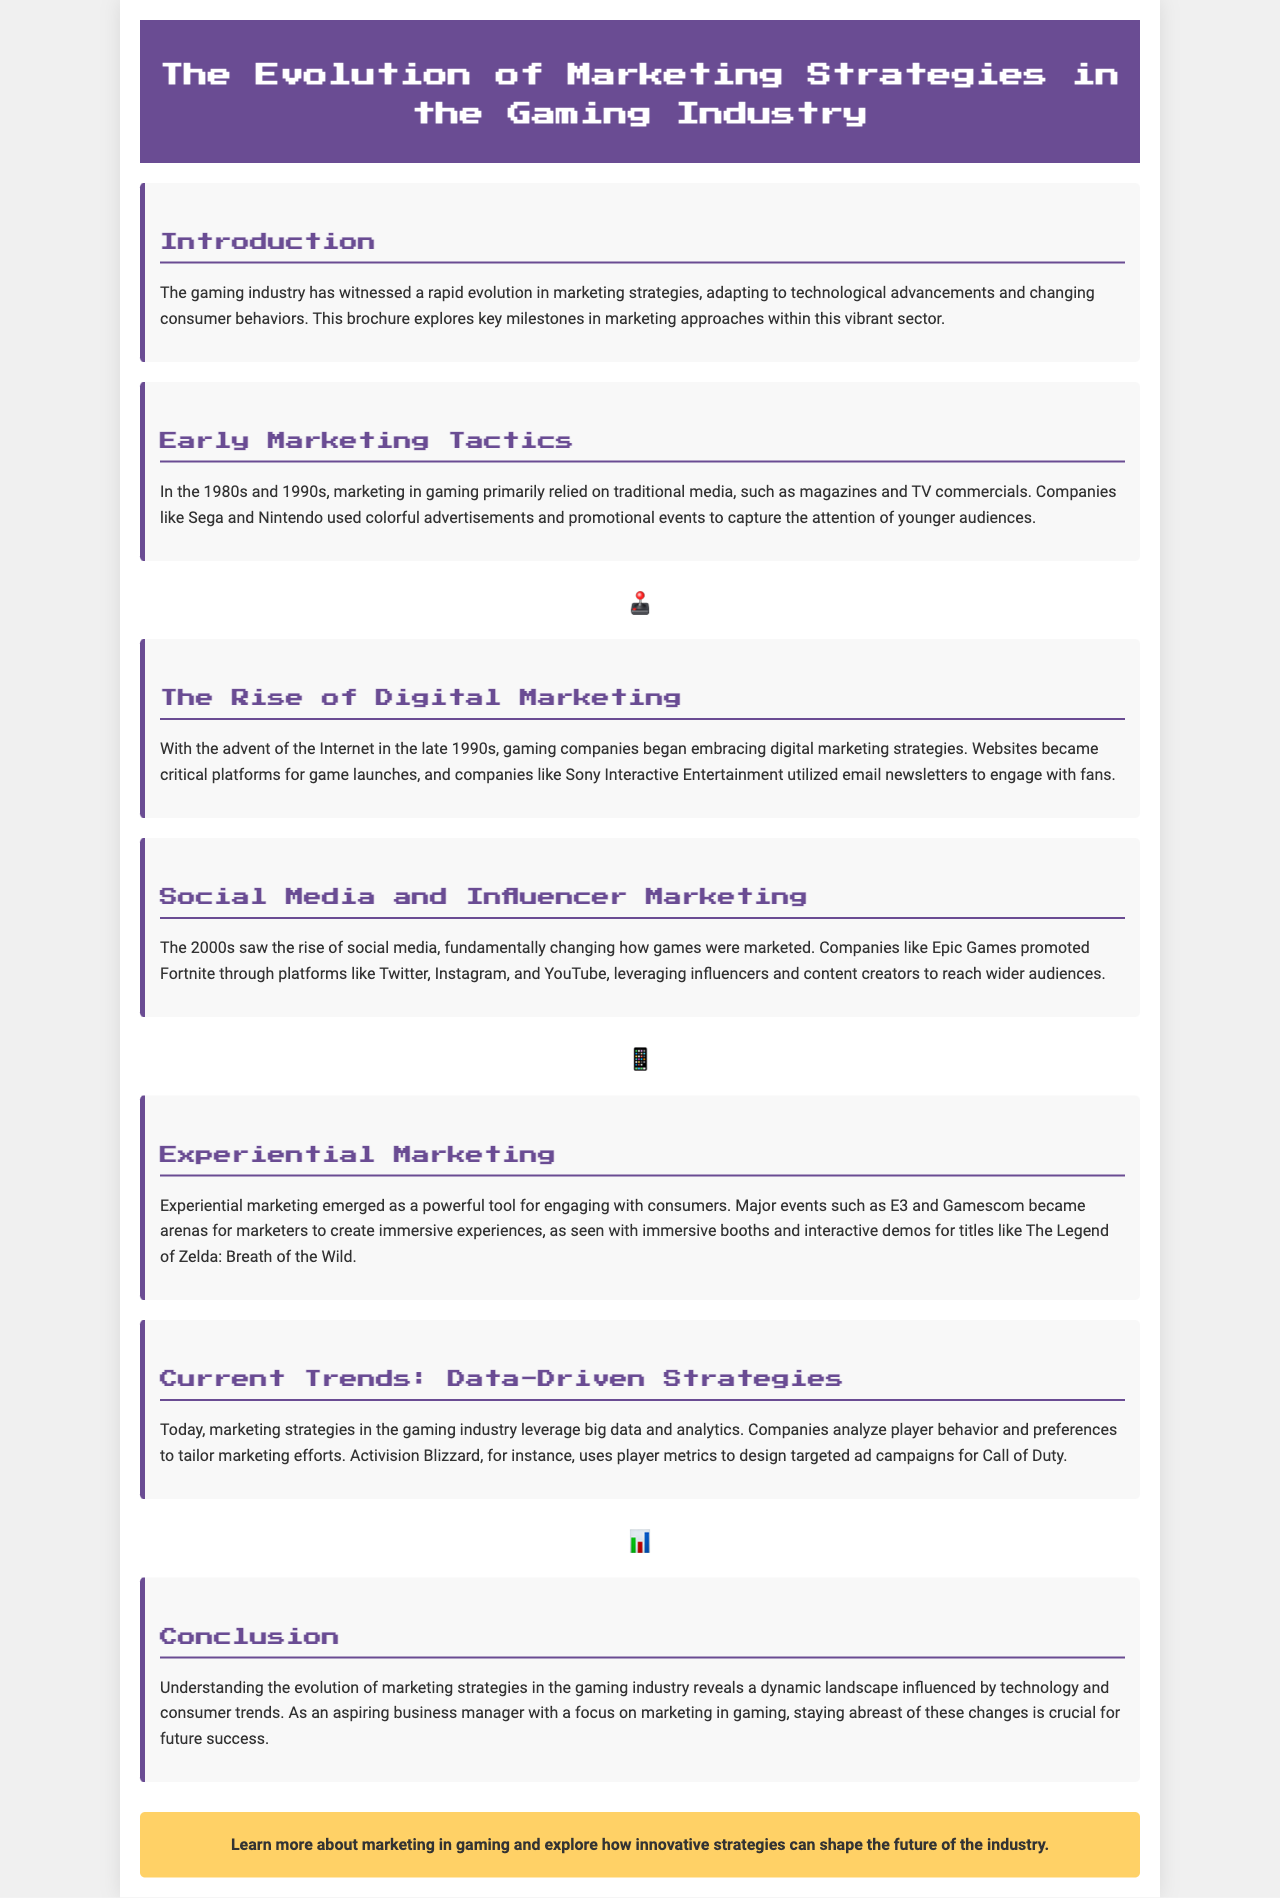What decade saw the use of traditional media in gaming marketing? The document indicates that marketing in gaming primarily relied on traditional media during the 1980s and 1990s.
Answer: 1980s and 1990s Which companies were highlighted for their early marketing tactics? The document names Sega and Nintendo as companies that used colorful advertisements and promotional events to market their products.
Answer: Sega and Nintendo What marketing strategy emerged from the rise of the Internet in the late 1990s? The brochure states that gaming companies began embracing digital marketing strategies.
Answer: Digital marketing strategies What social media platform did Epic Games use to promote Fortnite? The document identifies Twitter, Instagram, and YouTube as platforms used by Epic Games for promotion.
Answer: Twitter, Instagram, and YouTube Which gaming title was mentioned in relation to experiential marketing? The brochure notes The Legend of Zelda: Breath of the Wild as a title associated with experiential marketing.
Answer: The Legend of Zelda: Breath of the Wild What current trend in marketing emphasizes data and analytics? The document describes that marketing strategies in the gaming industry leverage big data and analytics.
Answer: Data-driven strategies What does the call-to-action at the end encourage readers to do? The call-to-action invites readers to learn more about marketing in gaming and explore innovative strategies.
Answer: Learn more about marketing in gaming Which major events are mentioned as part of experiential marketing? The document mentions E3 and Gamescom as major events for engaging consumers through marketing.
Answer: E3 and Gamescom 